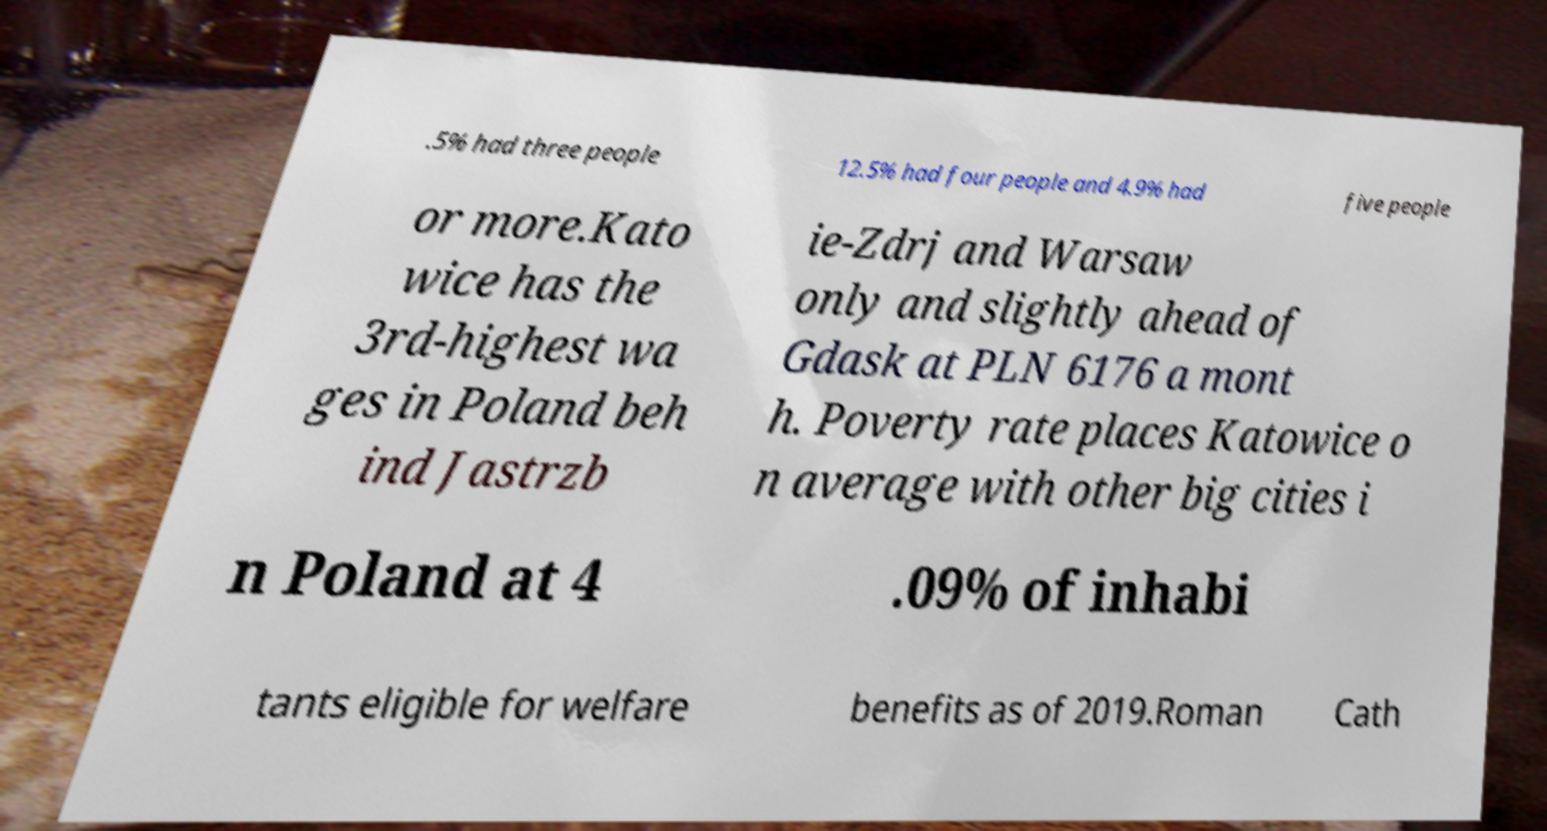Please identify and transcribe the text found in this image. .5% had three people 12.5% had four people and 4.9% had five people or more.Kato wice has the 3rd-highest wa ges in Poland beh ind Jastrzb ie-Zdrj and Warsaw only and slightly ahead of Gdask at PLN 6176 a mont h. Poverty rate places Katowice o n average with other big cities i n Poland at 4 .09% of inhabi tants eligible for welfare benefits as of 2019.Roman Cath 